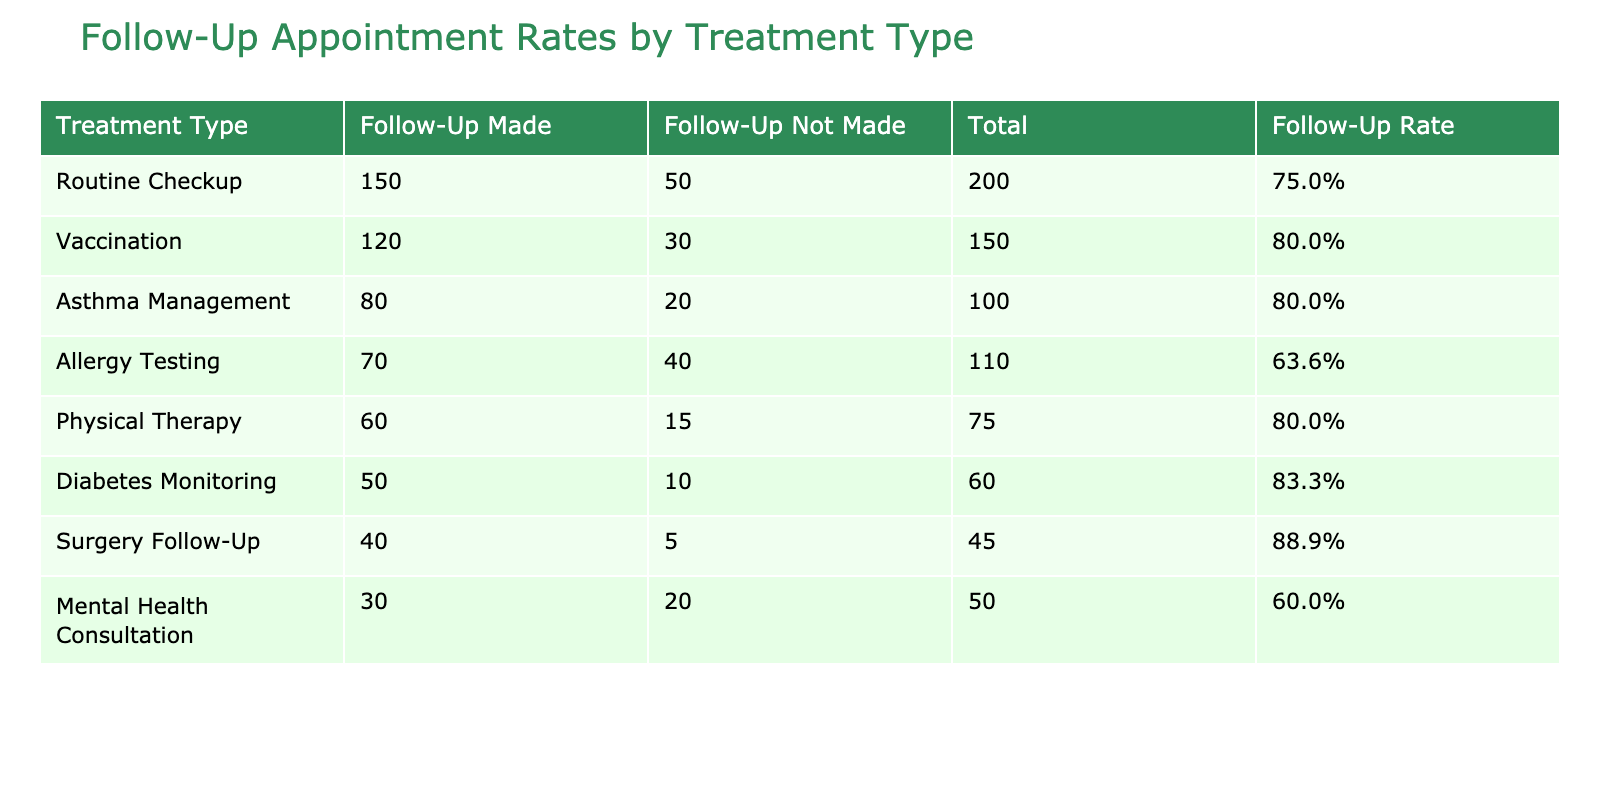What is the total number of follow-up appointments made for Routine Checkup? The table shows that 150 follow-up appointments were made for Routine Checkup.
Answer: 150 Which treatment type had the highest number of follow-up appointments not made? The table indicates that Allergy Testing had the highest number of follow-up appointments not made at 40.
Answer: 40 What is the follow-up appointment rate for Asthma Management? For Asthma Management, the follow-up appointment rate is calculated by dividing the follow-up appointments made (80) by the total appointments (100). So, 80/100 = 0.8, or 80%.
Answer: 80% How many total follow-up appointments were made across all treatment types? The total follow-up appointments made can be found by summing up all the "Follow-Up Appointment Made" values: 150 + 120 + 80 + 70 + 60 + 50 + 40 + 30 = 600.
Answer: 600 Is the follow-up appointment rate for Diabetes Monitoring greater than 80%? The follow-up appointment rate for Diabetes Monitoring is calculated as 50 made from a total of 60, which gives 50/60 = 0.833 or 83.3%. Therefore, it is indeed greater than 80%.
Answer: Yes What is the difference in follow-up appointments made between Vaccination and Physical Therapy? The number of follow-up appointments made for Vaccination is 120, while for Physical Therapy it is 60. The difference is calculated as 120 - 60 = 60.
Answer: 60 Which treatment type has the lowest follow-up appointment rate, and what is it? To determine the lowest follow-up appointment rate, consider the rates for all treatments. Mental Health Consultation has 30 made out of 50, which is 60%. This is lower than all others.
Answer: Mental Health Consultation, 60% What is the average follow-up appointment rate across all treatment types? To find the average, we calculate the rates for each treatment as follows: (150/200) + (120/150) + (80/100) + (70/110) + (60/75) + (50/60) + (40/45) + (30/50). Then we divide that sum by 8 (the number of treatment types) to get the average rate, which is approximately 74.4%.
Answer: 74.4% 